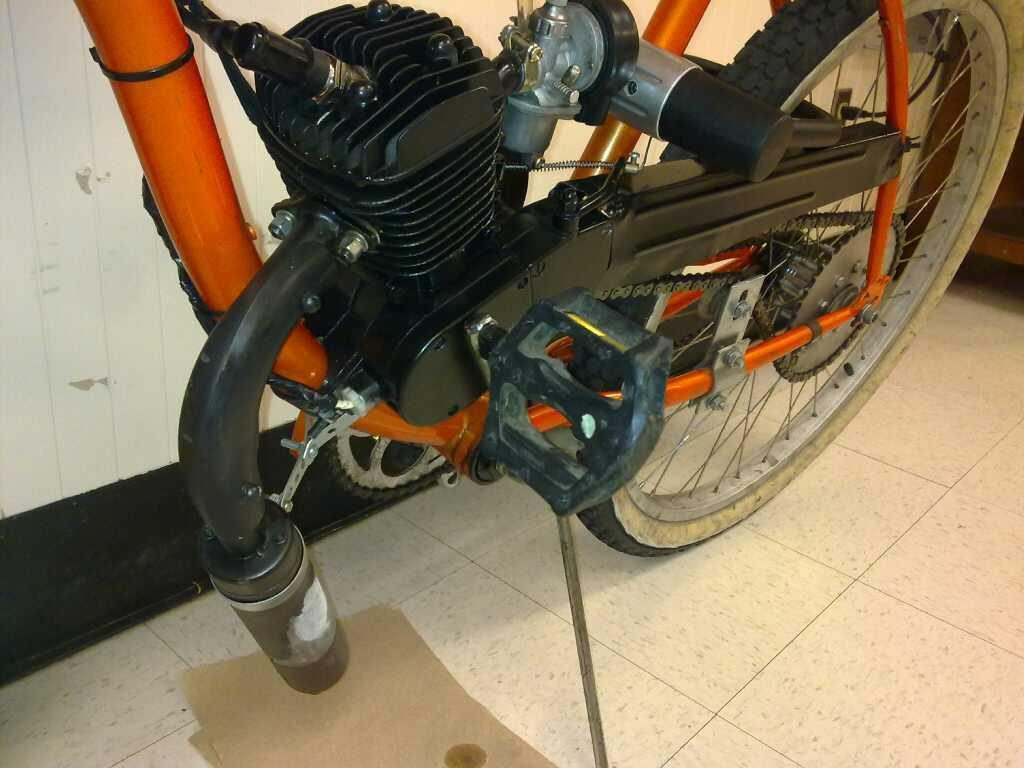What type of vehicle is on the floor in the image? There is a motorcycle on the floor in the image. What can be seen in the background of the image? There is a wall in the background of the image. What else is on the floor in the image besides the motorcycle? There is a paper placed on the floor in the image. What type of advertisement is hanging from the ceiling in the image? There is no advertisement hanging from the ceiling in the image; it only features a motorcycle, a wall, and a paper on the floor. 